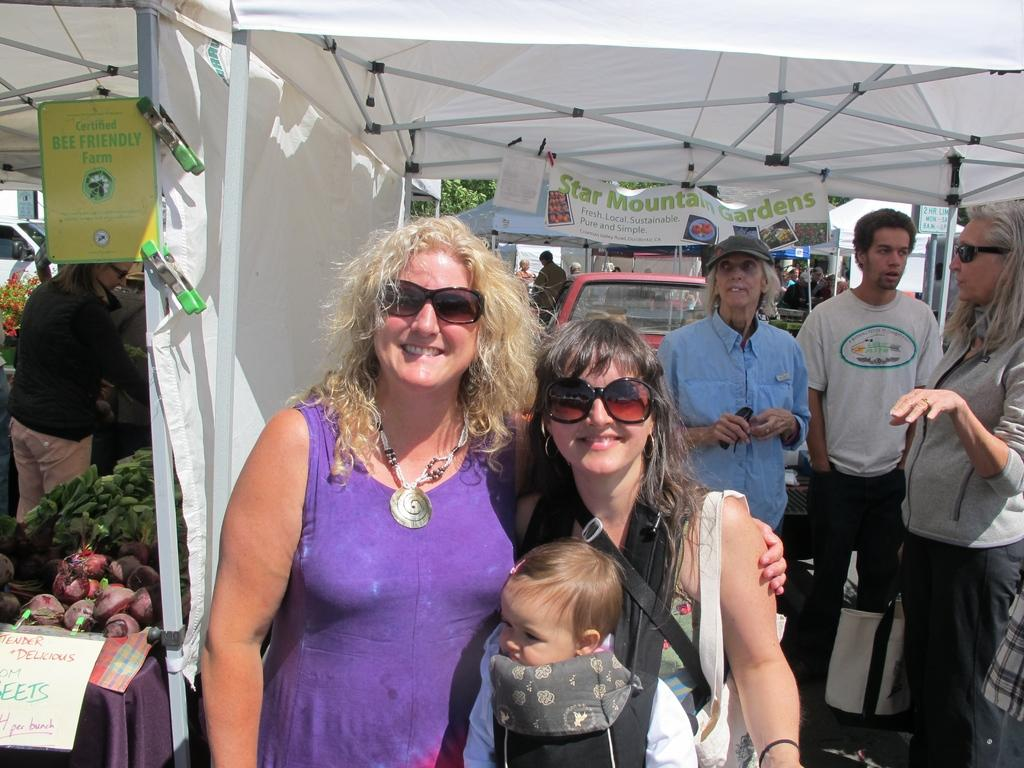What types of people are present in the image? There are men and women standing in the image. Is there a child present in the image? Yes, there is a child in the image. What can be seen in the image besides people? There is a vehicle, a poster, tents, and vegetables in the image. What type of stamp can be seen on the poster in the image? There is no stamp present on the poster in the image. Can you hear a whistle in the image? There is no whistle present in the image, so it cannot be heard. 